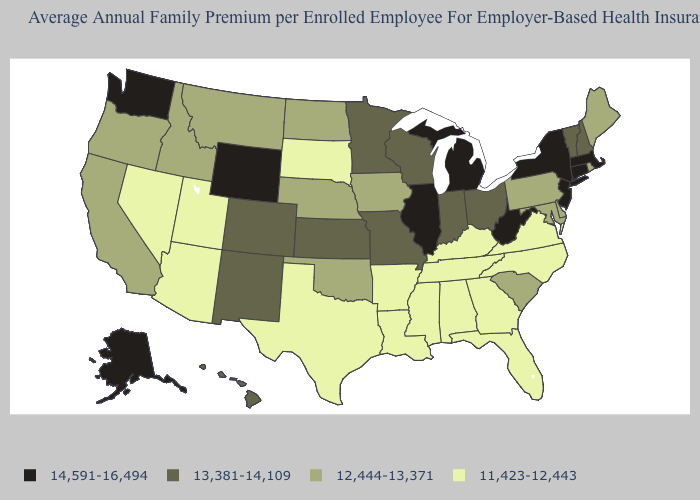Does South Dakota have the lowest value in the MidWest?
Short answer required. Yes. How many symbols are there in the legend?
Concise answer only. 4. What is the value of South Dakota?
Write a very short answer. 11,423-12,443. What is the lowest value in the USA?
Quick response, please. 11,423-12,443. Name the states that have a value in the range 14,591-16,494?
Write a very short answer. Alaska, Connecticut, Illinois, Massachusetts, Michigan, New Jersey, New York, Washington, West Virginia, Wyoming. What is the highest value in the USA?
Be succinct. 14,591-16,494. Name the states that have a value in the range 12,444-13,371?
Write a very short answer. California, Delaware, Idaho, Iowa, Maine, Maryland, Montana, Nebraska, North Dakota, Oklahoma, Oregon, Pennsylvania, Rhode Island, South Carolina. What is the value of Texas?
Answer briefly. 11,423-12,443. Does Massachusetts have a lower value than Alabama?
Quick response, please. No. Name the states that have a value in the range 13,381-14,109?
Quick response, please. Colorado, Hawaii, Indiana, Kansas, Minnesota, Missouri, New Hampshire, New Mexico, Ohio, Vermont, Wisconsin. Does the map have missing data?
Give a very brief answer. No. What is the value of Montana?
Give a very brief answer. 12,444-13,371. What is the lowest value in states that border Texas?
Keep it brief. 11,423-12,443. 